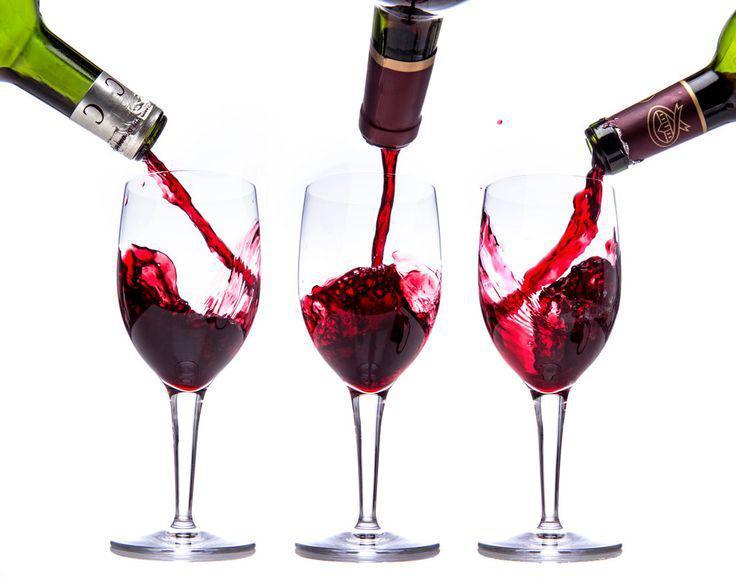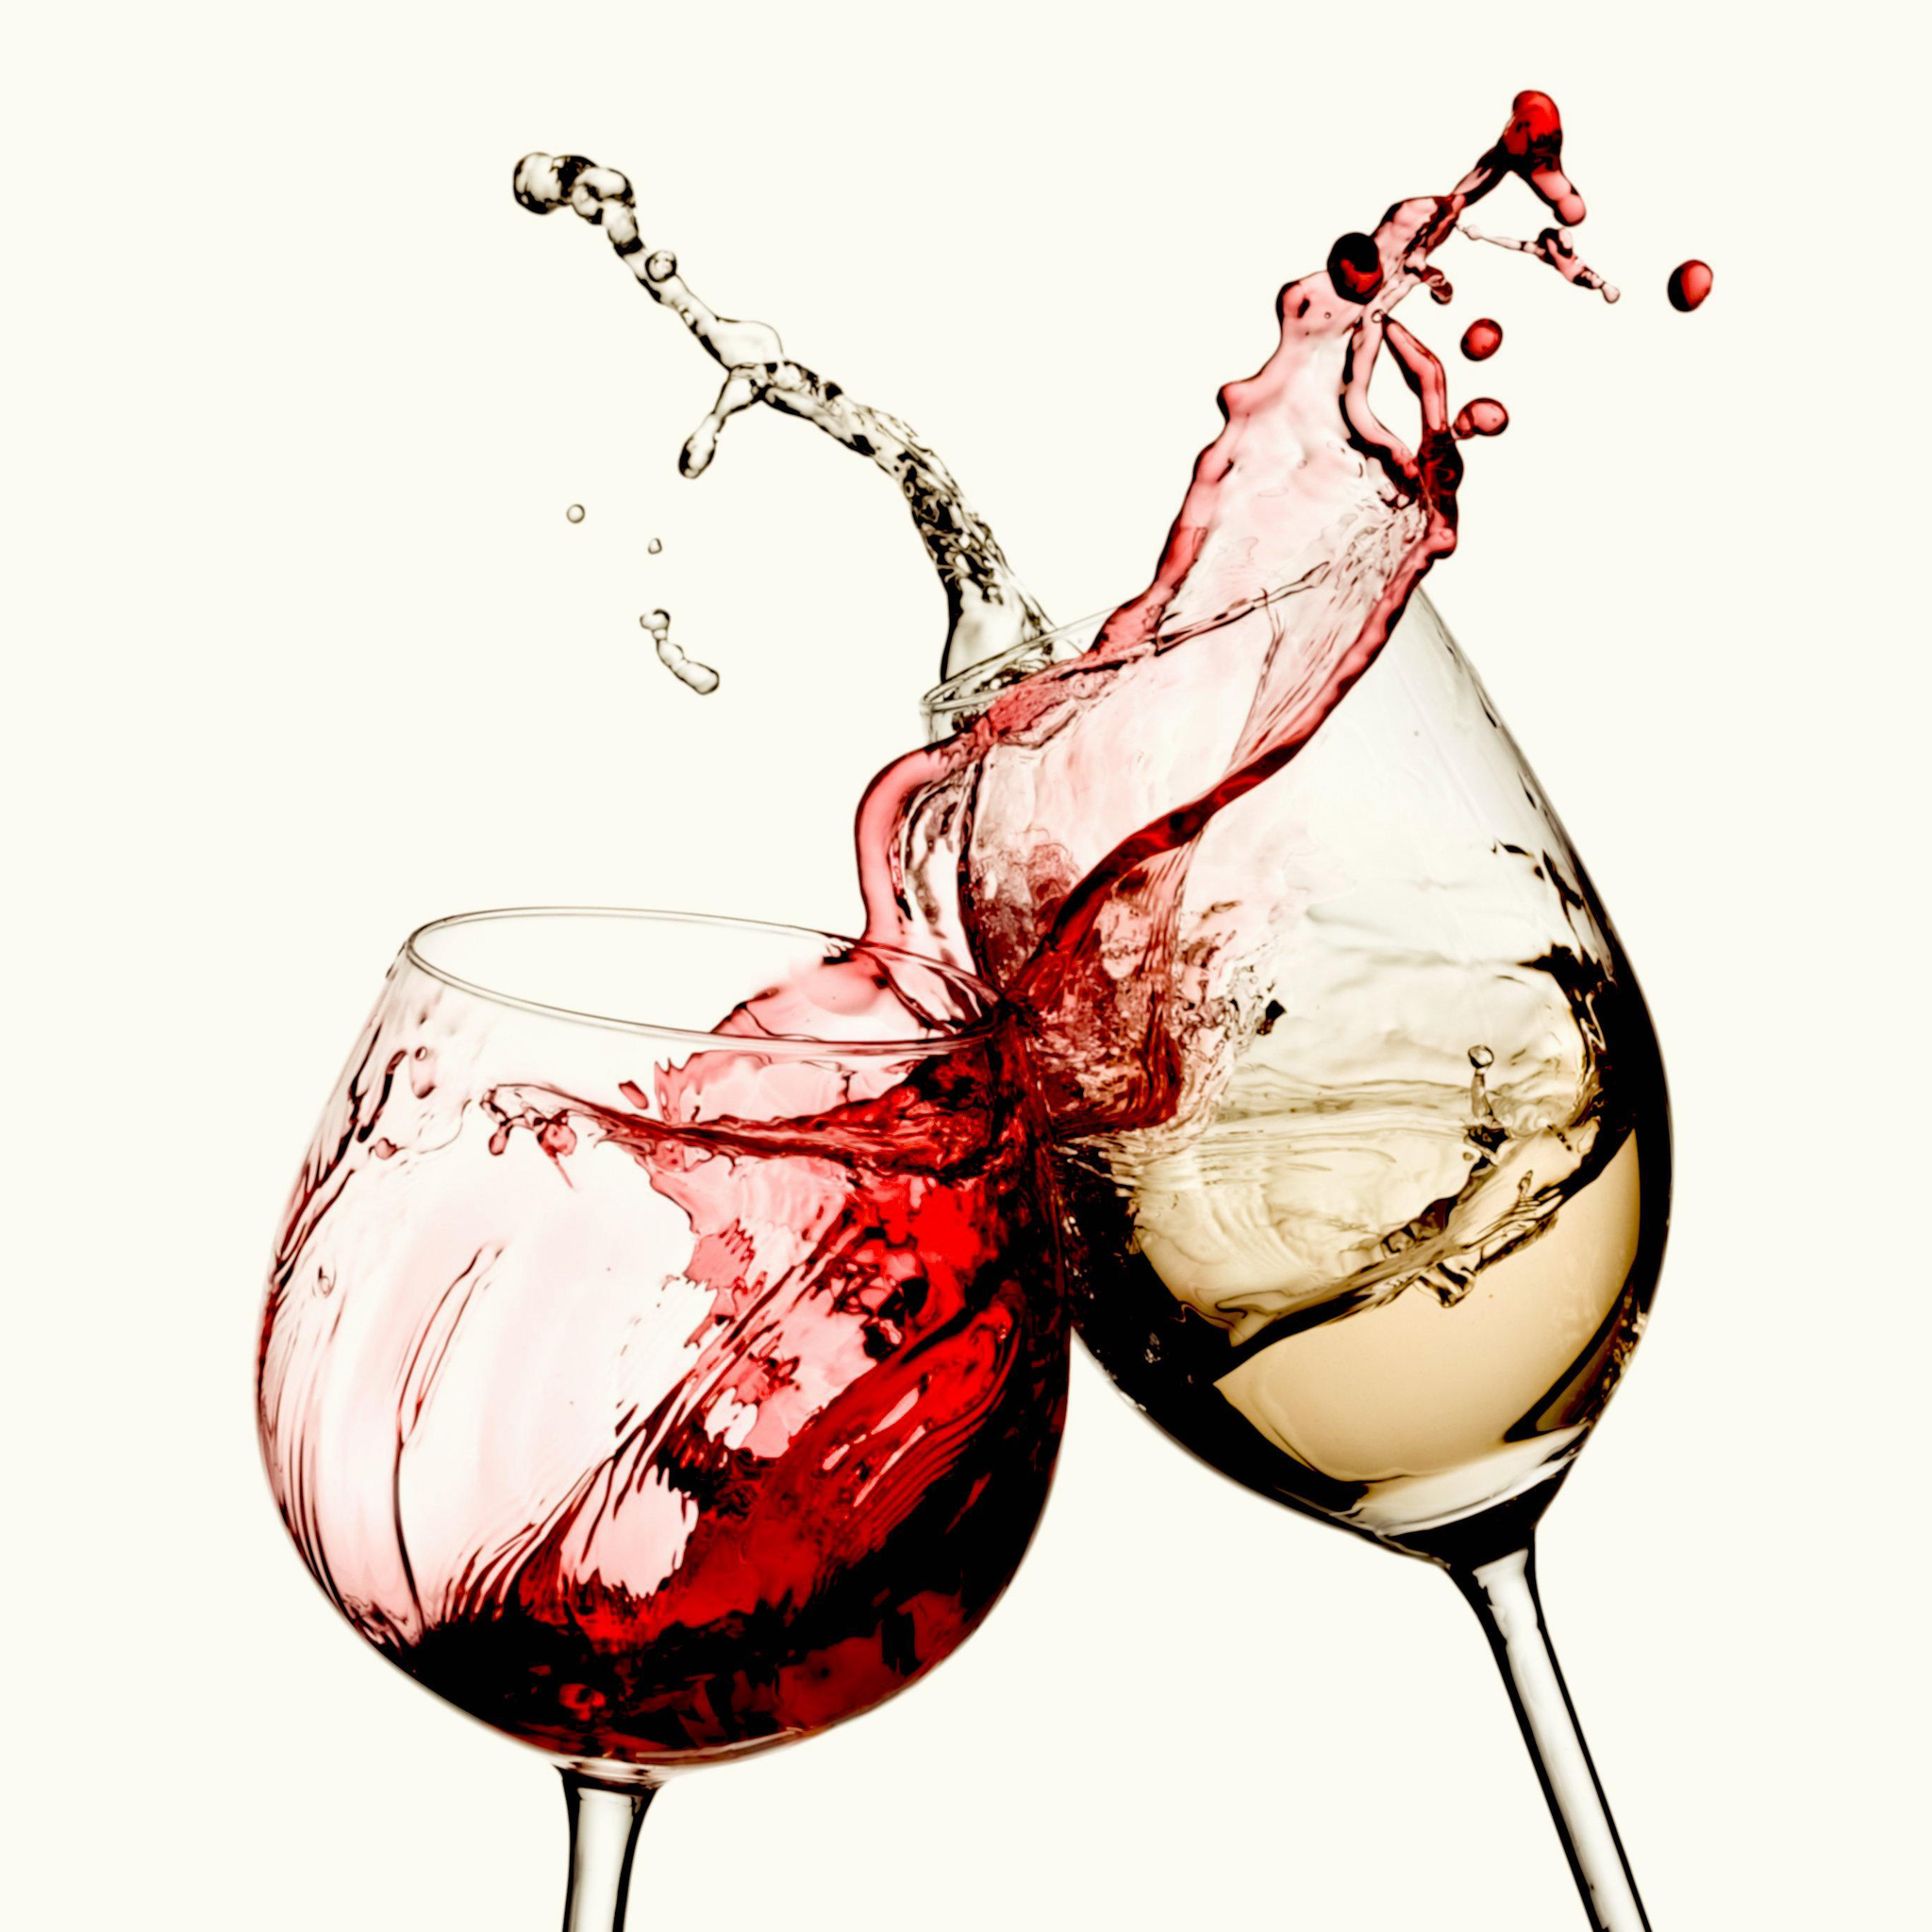The first image is the image on the left, the second image is the image on the right. For the images shown, is this caption "At least one of the images shows liquid in a glass that is stationary and not moving." true? Answer yes or no. No. 